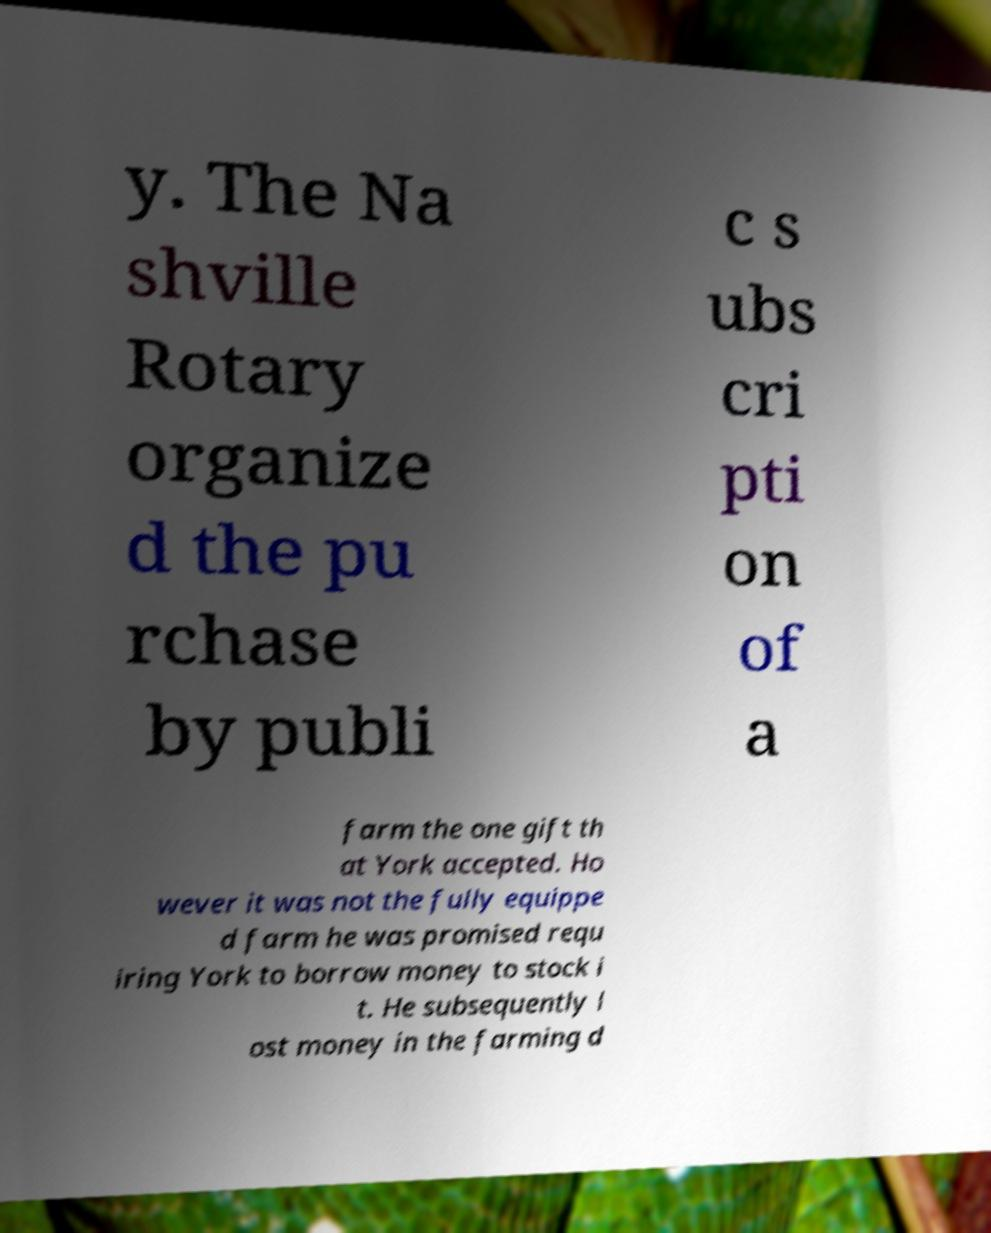For documentation purposes, I need the text within this image transcribed. Could you provide that? y. The Na shville Rotary organize d the pu rchase by publi c s ubs cri pti on of a farm the one gift th at York accepted. Ho wever it was not the fully equippe d farm he was promised requ iring York to borrow money to stock i t. He subsequently l ost money in the farming d 